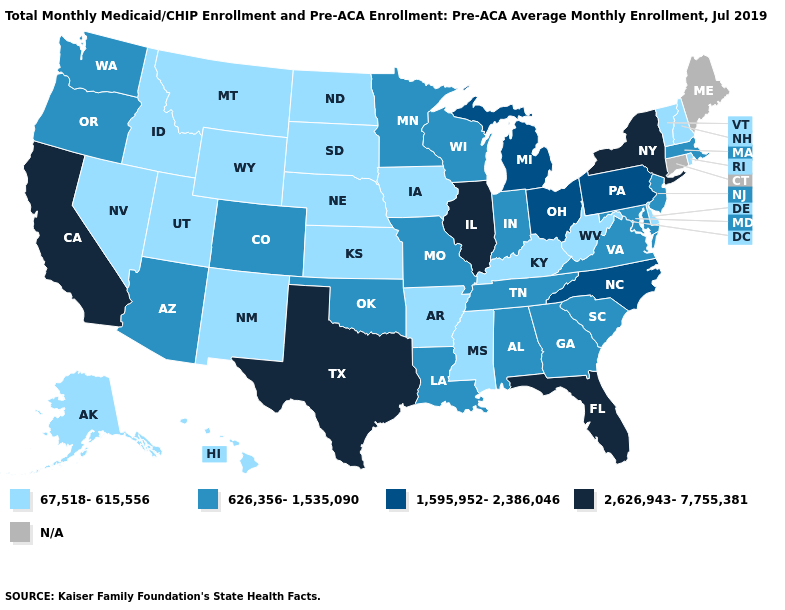Does New York have the lowest value in the USA?
Quick response, please. No. Name the states that have a value in the range 2,626,943-7,755,381?
Answer briefly. California, Florida, Illinois, New York, Texas. Among the states that border Missouri , which have the lowest value?
Concise answer only. Arkansas, Iowa, Kansas, Kentucky, Nebraska. Is the legend a continuous bar?
Concise answer only. No. Name the states that have a value in the range 2,626,943-7,755,381?
Concise answer only. California, Florida, Illinois, New York, Texas. Name the states that have a value in the range 2,626,943-7,755,381?
Write a very short answer. California, Florida, Illinois, New York, Texas. What is the highest value in the USA?
Keep it brief. 2,626,943-7,755,381. Name the states that have a value in the range 626,356-1,535,090?
Write a very short answer. Alabama, Arizona, Colorado, Georgia, Indiana, Louisiana, Maryland, Massachusetts, Minnesota, Missouri, New Jersey, Oklahoma, Oregon, South Carolina, Tennessee, Virginia, Washington, Wisconsin. Does Kansas have the lowest value in the MidWest?
Give a very brief answer. Yes. What is the value of Louisiana?
Quick response, please. 626,356-1,535,090. Among the states that border North Dakota , which have the lowest value?
Answer briefly. Montana, South Dakota. What is the highest value in the West ?
Keep it brief. 2,626,943-7,755,381. Among the states that border Virginia , which have the lowest value?
Short answer required. Kentucky, West Virginia. Does Oregon have the lowest value in the USA?
Quick response, please. No. Is the legend a continuous bar?
Keep it brief. No. 